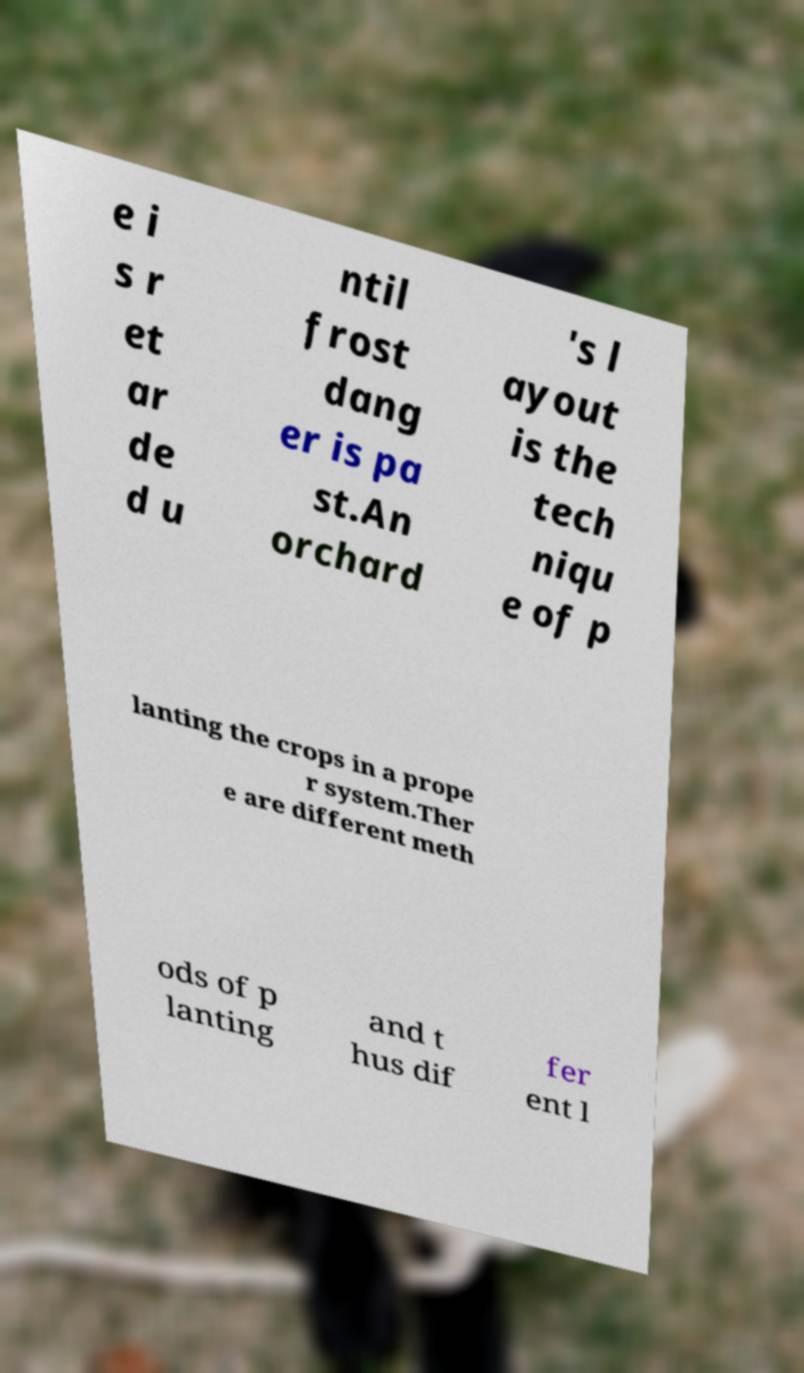Could you assist in decoding the text presented in this image and type it out clearly? e i s r et ar de d u ntil frost dang er is pa st.An orchard 's l ayout is the tech niqu e of p lanting the crops in a prope r system.Ther e are different meth ods of p lanting and t hus dif fer ent l 